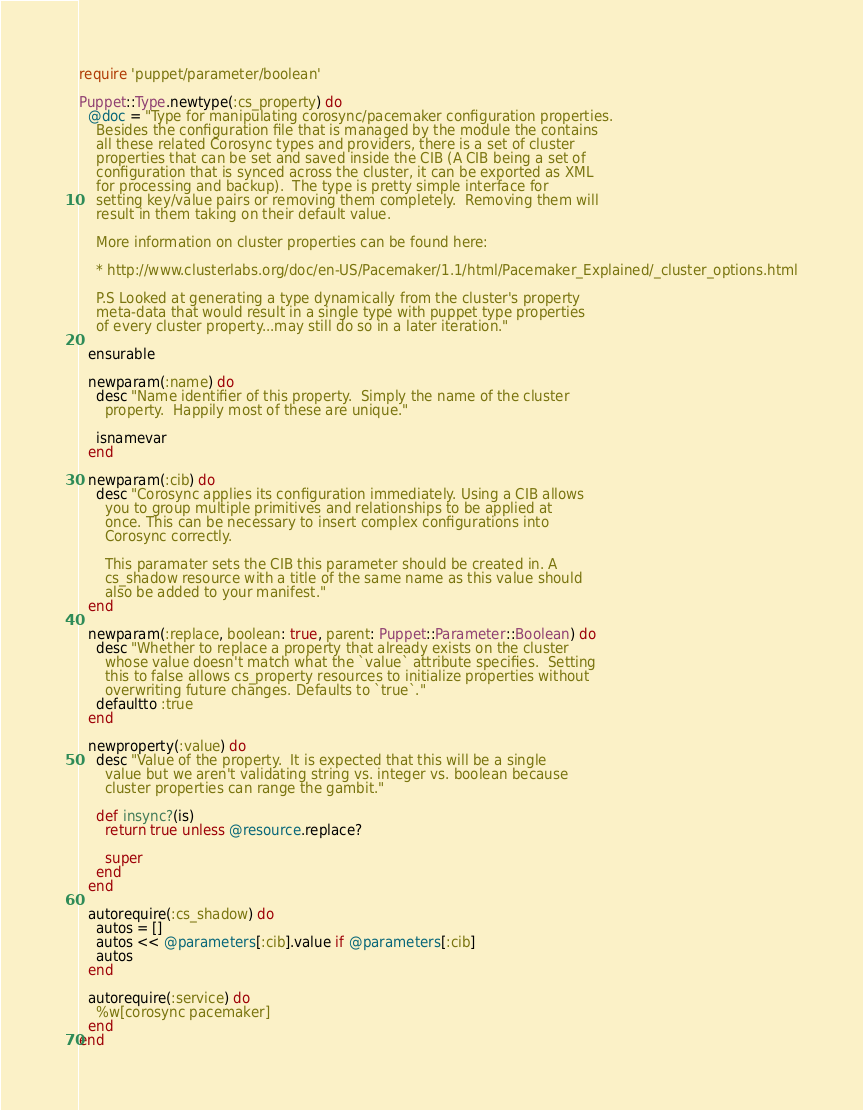<code> <loc_0><loc_0><loc_500><loc_500><_Ruby_>require 'puppet/parameter/boolean'

Puppet::Type.newtype(:cs_property) do
  @doc = "Type for manipulating corosync/pacemaker configuration properties.
    Besides the configuration file that is managed by the module the contains
    all these related Corosync types and providers, there is a set of cluster
    properties that can be set and saved inside the CIB (A CIB being a set of
    configuration that is synced across the cluster, it can be exported as XML
    for processing and backup).  The type is pretty simple interface for
    setting key/value pairs or removing them completely.  Removing them will
    result in them taking on their default value.

    More information on cluster properties can be found here:

    * http://www.clusterlabs.org/doc/en-US/Pacemaker/1.1/html/Pacemaker_Explained/_cluster_options.html

    P.S Looked at generating a type dynamically from the cluster's property
    meta-data that would result in a single type with puppet type properties
    of every cluster property...may still do so in a later iteration."

  ensurable

  newparam(:name) do
    desc "Name identifier of this property.  Simply the name of the cluster
      property.  Happily most of these are unique."

    isnamevar
  end

  newparam(:cib) do
    desc "Corosync applies its configuration immediately. Using a CIB allows
      you to group multiple primitives and relationships to be applied at
      once. This can be necessary to insert complex configurations into
      Corosync correctly.

      This paramater sets the CIB this parameter should be created in. A
      cs_shadow resource with a title of the same name as this value should
      also be added to your manifest."
  end

  newparam(:replace, boolean: true, parent: Puppet::Parameter::Boolean) do
    desc "Whether to replace a property that already exists on the cluster
      whose value doesn't match what the `value` attribute specifies.  Setting
      this to false allows cs_property resources to initialize properties without
      overwriting future changes. Defaults to `true`."
    defaultto :true
  end

  newproperty(:value) do
    desc "Value of the property.  It is expected that this will be a single
      value but we aren't validating string vs. integer vs. boolean because
      cluster properties can range the gambit."

    def insync?(is)
      return true unless @resource.replace?

      super
    end
  end

  autorequire(:cs_shadow) do
    autos = []
    autos << @parameters[:cib].value if @parameters[:cib]
    autos
  end

  autorequire(:service) do
    %w[corosync pacemaker]
  end
end
</code> 